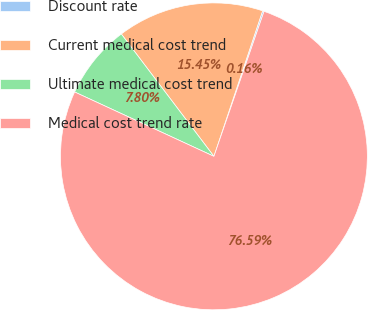Convert chart to OTSL. <chart><loc_0><loc_0><loc_500><loc_500><pie_chart><fcel>Discount rate<fcel>Current medical cost trend<fcel>Ultimate medical cost trend<fcel>Medical cost trend rate<nl><fcel>0.16%<fcel>15.45%<fcel>7.8%<fcel>76.59%<nl></chart> 